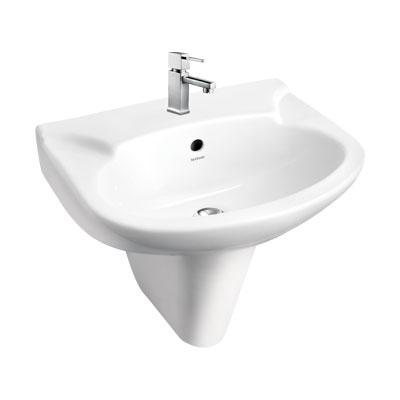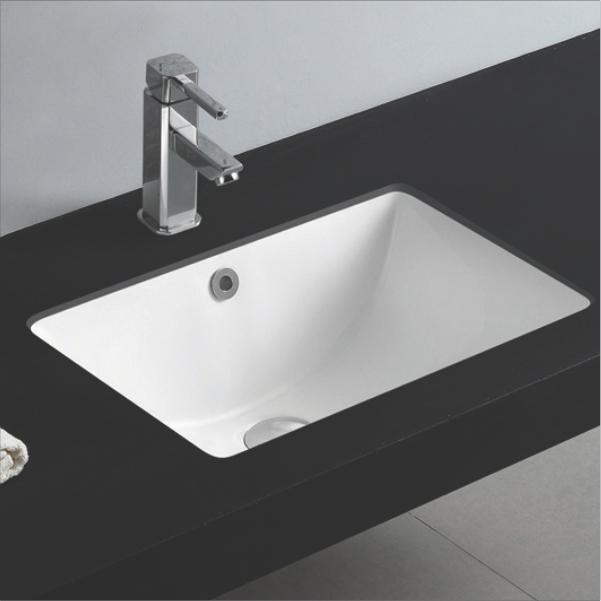The first image is the image on the left, the second image is the image on the right. For the images displayed, is the sentence "Two white sinks have center faucets and are mounted so the outer sink is shown." factually correct? Answer yes or no. No. The first image is the image on the left, the second image is the image on the right. Assess this claim about the two images: "The sink on the right has a rectangular shape.". Correct or not? Answer yes or no. Yes. 